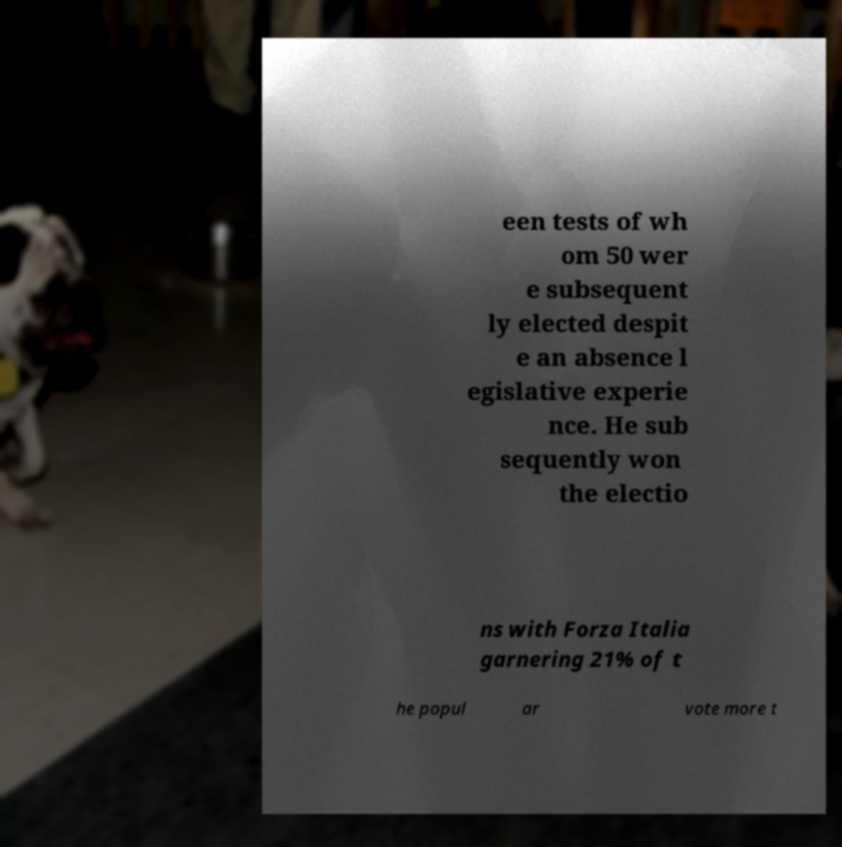Could you assist in decoding the text presented in this image and type it out clearly? een tests of wh om 50 wer e subsequent ly elected despit e an absence l egislative experie nce. He sub sequently won the electio ns with Forza Italia garnering 21% of t he popul ar vote more t 